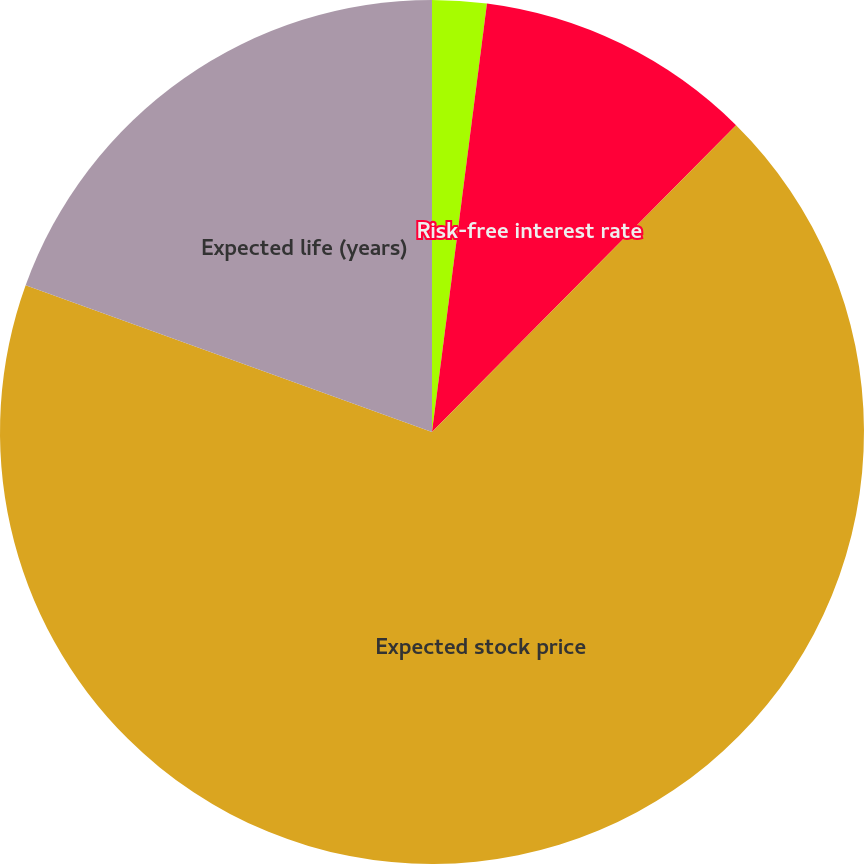<chart> <loc_0><loc_0><loc_500><loc_500><pie_chart><fcel>Expected dividend yield<fcel>Risk-free interest rate<fcel>Expected stock price<fcel>Expected life (years)<nl><fcel>2.03%<fcel>10.4%<fcel>68.09%<fcel>19.49%<nl></chart> 